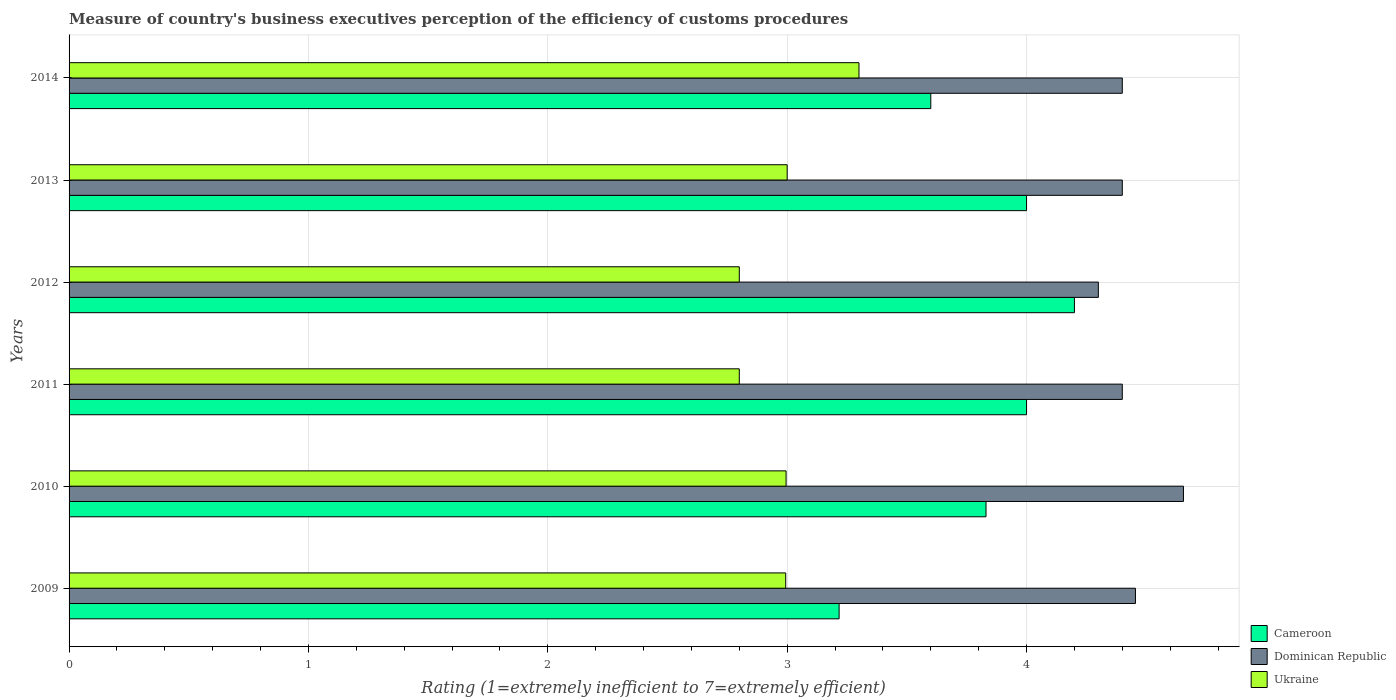How many groups of bars are there?
Give a very brief answer. 6. Are the number of bars per tick equal to the number of legend labels?
Give a very brief answer. Yes. Are the number of bars on each tick of the Y-axis equal?
Provide a succinct answer. Yes. How many bars are there on the 1st tick from the top?
Ensure brevity in your answer.  3. In how many cases, is the number of bars for a given year not equal to the number of legend labels?
Your response must be concise. 0. In which year was the rating of the efficiency of customs procedure in Dominican Republic maximum?
Keep it short and to the point. 2010. In which year was the rating of the efficiency of customs procedure in Dominican Republic minimum?
Offer a very short reply. 2012. What is the total rating of the efficiency of customs procedure in Ukraine in the graph?
Offer a terse response. 17.89. What is the difference between the rating of the efficiency of customs procedure in Ukraine in 2010 and that in 2013?
Your response must be concise. -0. What is the difference between the rating of the efficiency of customs procedure in Cameroon in 2009 and the rating of the efficiency of customs procedure in Dominican Republic in 2013?
Offer a very short reply. -1.18. What is the average rating of the efficiency of customs procedure in Dominican Republic per year?
Make the answer very short. 4.44. In the year 2014, what is the difference between the rating of the efficiency of customs procedure in Ukraine and rating of the efficiency of customs procedure in Dominican Republic?
Provide a succinct answer. -1.1. In how many years, is the rating of the efficiency of customs procedure in Cameroon greater than 2.8 ?
Your response must be concise. 6. What is the ratio of the rating of the efficiency of customs procedure in Cameroon in 2009 to that in 2010?
Offer a very short reply. 0.84. What is the difference between the highest and the second highest rating of the efficiency of customs procedure in Cameroon?
Offer a very short reply. 0.2. What is the difference between the highest and the lowest rating of the efficiency of customs procedure in Ukraine?
Make the answer very short. 0.5. Is the sum of the rating of the efficiency of customs procedure in Dominican Republic in 2010 and 2014 greater than the maximum rating of the efficiency of customs procedure in Cameroon across all years?
Provide a short and direct response. Yes. What does the 1st bar from the top in 2010 represents?
Your response must be concise. Ukraine. What does the 2nd bar from the bottom in 2009 represents?
Your answer should be very brief. Dominican Republic. Is it the case that in every year, the sum of the rating of the efficiency of customs procedure in Cameroon and rating of the efficiency of customs procedure in Ukraine is greater than the rating of the efficiency of customs procedure in Dominican Republic?
Your response must be concise. Yes. Are all the bars in the graph horizontal?
Make the answer very short. Yes. What is the difference between two consecutive major ticks on the X-axis?
Provide a short and direct response. 1. How many legend labels are there?
Your answer should be very brief. 3. What is the title of the graph?
Your response must be concise. Measure of country's business executives perception of the efficiency of customs procedures. What is the label or title of the X-axis?
Your response must be concise. Rating (1=extremely inefficient to 7=extremely efficient). What is the label or title of the Y-axis?
Offer a terse response. Years. What is the Rating (1=extremely inefficient to 7=extremely efficient) in Cameroon in 2009?
Keep it short and to the point. 3.22. What is the Rating (1=extremely inefficient to 7=extremely efficient) in Dominican Republic in 2009?
Offer a terse response. 4.46. What is the Rating (1=extremely inefficient to 7=extremely efficient) in Ukraine in 2009?
Offer a very short reply. 2.99. What is the Rating (1=extremely inefficient to 7=extremely efficient) of Cameroon in 2010?
Make the answer very short. 3.83. What is the Rating (1=extremely inefficient to 7=extremely efficient) of Dominican Republic in 2010?
Your response must be concise. 4.66. What is the Rating (1=extremely inefficient to 7=extremely efficient) in Ukraine in 2010?
Your answer should be compact. 3. What is the Rating (1=extremely inefficient to 7=extremely efficient) of Dominican Republic in 2011?
Your answer should be very brief. 4.4. What is the Rating (1=extremely inefficient to 7=extremely efficient) in Cameroon in 2012?
Give a very brief answer. 4.2. What is the Rating (1=extremely inefficient to 7=extremely efficient) in Dominican Republic in 2012?
Provide a succinct answer. 4.3. What is the Rating (1=extremely inefficient to 7=extremely efficient) in Ukraine in 2012?
Make the answer very short. 2.8. What is the Rating (1=extremely inefficient to 7=extremely efficient) of Cameroon in 2013?
Your answer should be very brief. 4. What is the Rating (1=extremely inefficient to 7=extremely efficient) of Dominican Republic in 2013?
Give a very brief answer. 4.4. What is the Rating (1=extremely inefficient to 7=extremely efficient) of Ukraine in 2013?
Provide a succinct answer. 3. What is the Rating (1=extremely inefficient to 7=extremely efficient) of Cameroon in 2014?
Make the answer very short. 3.6. What is the Rating (1=extremely inefficient to 7=extremely efficient) in Dominican Republic in 2014?
Your answer should be very brief. 4.4. Across all years, what is the maximum Rating (1=extremely inefficient to 7=extremely efficient) in Dominican Republic?
Offer a terse response. 4.66. Across all years, what is the maximum Rating (1=extremely inefficient to 7=extremely efficient) of Ukraine?
Your response must be concise. 3.3. Across all years, what is the minimum Rating (1=extremely inefficient to 7=extremely efficient) of Cameroon?
Offer a terse response. 3.22. Across all years, what is the minimum Rating (1=extremely inefficient to 7=extremely efficient) in Dominican Republic?
Give a very brief answer. 4.3. What is the total Rating (1=extremely inefficient to 7=extremely efficient) in Cameroon in the graph?
Make the answer very short. 22.85. What is the total Rating (1=extremely inefficient to 7=extremely efficient) in Dominican Republic in the graph?
Your answer should be compact. 26.61. What is the total Rating (1=extremely inefficient to 7=extremely efficient) of Ukraine in the graph?
Your answer should be compact. 17.89. What is the difference between the Rating (1=extremely inefficient to 7=extremely efficient) of Cameroon in 2009 and that in 2010?
Make the answer very short. -0.61. What is the difference between the Rating (1=extremely inefficient to 7=extremely efficient) of Dominican Republic in 2009 and that in 2010?
Offer a very short reply. -0.2. What is the difference between the Rating (1=extremely inefficient to 7=extremely efficient) in Ukraine in 2009 and that in 2010?
Offer a very short reply. -0. What is the difference between the Rating (1=extremely inefficient to 7=extremely efficient) of Cameroon in 2009 and that in 2011?
Make the answer very short. -0.78. What is the difference between the Rating (1=extremely inefficient to 7=extremely efficient) of Dominican Republic in 2009 and that in 2011?
Provide a succinct answer. 0.06. What is the difference between the Rating (1=extremely inefficient to 7=extremely efficient) of Ukraine in 2009 and that in 2011?
Your response must be concise. 0.19. What is the difference between the Rating (1=extremely inefficient to 7=extremely efficient) of Cameroon in 2009 and that in 2012?
Offer a terse response. -0.98. What is the difference between the Rating (1=extremely inefficient to 7=extremely efficient) of Dominican Republic in 2009 and that in 2012?
Ensure brevity in your answer.  0.15. What is the difference between the Rating (1=extremely inefficient to 7=extremely efficient) of Ukraine in 2009 and that in 2012?
Your answer should be compact. 0.19. What is the difference between the Rating (1=extremely inefficient to 7=extremely efficient) in Cameroon in 2009 and that in 2013?
Your answer should be compact. -0.78. What is the difference between the Rating (1=extremely inefficient to 7=extremely efficient) of Dominican Republic in 2009 and that in 2013?
Offer a very short reply. 0.06. What is the difference between the Rating (1=extremely inefficient to 7=extremely efficient) in Ukraine in 2009 and that in 2013?
Ensure brevity in your answer.  -0.01. What is the difference between the Rating (1=extremely inefficient to 7=extremely efficient) in Cameroon in 2009 and that in 2014?
Keep it short and to the point. -0.38. What is the difference between the Rating (1=extremely inefficient to 7=extremely efficient) of Dominican Republic in 2009 and that in 2014?
Keep it short and to the point. 0.06. What is the difference between the Rating (1=extremely inefficient to 7=extremely efficient) of Ukraine in 2009 and that in 2014?
Your answer should be very brief. -0.31. What is the difference between the Rating (1=extremely inefficient to 7=extremely efficient) in Cameroon in 2010 and that in 2011?
Your answer should be compact. -0.17. What is the difference between the Rating (1=extremely inefficient to 7=extremely efficient) of Dominican Republic in 2010 and that in 2011?
Offer a terse response. 0.26. What is the difference between the Rating (1=extremely inefficient to 7=extremely efficient) of Ukraine in 2010 and that in 2011?
Offer a terse response. 0.2. What is the difference between the Rating (1=extremely inefficient to 7=extremely efficient) of Cameroon in 2010 and that in 2012?
Your answer should be compact. -0.37. What is the difference between the Rating (1=extremely inefficient to 7=extremely efficient) of Dominican Republic in 2010 and that in 2012?
Provide a succinct answer. 0.36. What is the difference between the Rating (1=extremely inefficient to 7=extremely efficient) in Ukraine in 2010 and that in 2012?
Give a very brief answer. 0.2. What is the difference between the Rating (1=extremely inefficient to 7=extremely efficient) of Cameroon in 2010 and that in 2013?
Keep it short and to the point. -0.17. What is the difference between the Rating (1=extremely inefficient to 7=extremely efficient) in Dominican Republic in 2010 and that in 2013?
Your answer should be compact. 0.26. What is the difference between the Rating (1=extremely inefficient to 7=extremely efficient) in Ukraine in 2010 and that in 2013?
Provide a succinct answer. -0. What is the difference between the Rating (1=extremely inefficient to 7=extremely efficient) of Cameroon in 2010 and that in 2014?
Your answer should be compact. 0.23. What is the difference between the Rating (1=extremely inefficient to 7=extremely efficient) in Dominican Republic in 2010 and that in 2014?
Your answer should be compact. 0.26. What is the difference between the Rating (1=extremely inefficient to 7=extremely efficient) in Ukraine in 2010 and that in 2014?
Provide a succinct answer. -0.3. What is the difference between the Rating (1=extremely inefficient to 7=extremely efficient) of Cameroon in 2011 and that in 2012?
Ensure brevity in your answer.  -0.2. What is the difference between the Rating (1=extremely inefficient to 7=extremely efficient) of Ukraine in 2011 and that in 2012?
Make the answer very short. 0. What is the difference between the Rating (1=extremely inefficient to 7=extremely efficient) of Cameroon in 2011 and that in 2013?
Keep it short and to the point. 0. What is the difference between the Rating (1=extremely inefficient to 7=extremely efficient) in Dominican Republic in 2011 and that in 2013?
Your answer should be very brief. 0. What is the difference between the Rating (1=extremely inefficient to 7=extremely efficient) of Ukraine in 2011 and that in 2013?
Keep it short and to the point. -0.2. What is the difference between the Rating (1=extremely inefficient to 7=extremely efficient) in Cameroon in 2012 and that in 2013?
Make the answer very short. 0.2. What is the difference between the Rating (1=extremely inefficient to 7=extremely efficient) in Cameroon in 2012 and that in 2014?
Your response must be concise. 0.6. What is the difference between the Rating (1=extremely inefficient to 7=extremely efficient) of Dominican Republic in 2012 and that in 2014?
Keep it short and to the point. -0.1. What is the difference between the Rating (1=extremely inefficient to 7=extremely efficient) of Cameroon in 2013 and that in 2014?
Provide a succinct answer. 0.4. What is the difference between the Rating (1=extremely inefficient to 7=extremely efficient) of Ukraine in 2013 and that in 2014?
Your answer should be compact. -0.3. What is the difference between the Rating (1=extremely inefficient to 7=extremely efficient) in Cameroon in 2009 and the Rating (1=extremely inefficient to 7=extremely efficient) in Dominican Republic in 2010?
Offer a terse response. -1.44. What is the difference between the Rating (1=extremely inefficient to 7=extremely efficient) in Cameroon in 2009 and the Rating (1=extremely inefficient to 7=extremely efficient) in Ukraine in 2010?
Provide a succinct answer. 0.22. What is the difference between the Rating (1=extremely inefficient to 7=extremely efficient) of Dominican Republic in 2009 and the Rating (1=extremely inefficient to 7=extremely efficient) of Ukraine in 2010?
Give a very brief answer. 1.46. What is the difference between the Rating (1=extremely inefficient to 7=extremely efficient) in Cameroon in 2009 and the Rating (1=extremely inefficient to 7=extremely efficient) in Dominican Republic in 2011?
Ensure brevity in your answer.  -1.18. What is the difference between the Rating (1=extremely inefficient to 7=extremely efficient) in Cameroon in 2009 and the Rating (1=extremely inefficient to 7=extremely efficient) in Ukraine in 2011?
Provide a succinct answer. 0.42. What is the difference between the Rating (1=extremely inefficient to 7=extremely efficient) in Dominican Republic in 2009 and the Rating (1=extremely inefficient to 7=extremely efficient) in Ukraine in 2011?
Offer a very short reply. 1.66. What is the difference between the Rating (1=extremely inefficient to 7=extremely efficient) in Cameroon in 2009 and the Rating (1=extremely inefficient to 7=extremely efficient) in Dominican Republic in 2012?
Provide a short and direct response. -1.08. What is the difference between the Rating (1=extremely inefficient to 7=extremely efficient) of Cameroon in 2009 and the Rating (1=extremely inefficient to 7=extremely efficient) of Ukraine in 2012?
Your answer should be very brief. 0.42. What is the difference between the Rating (1=extremely inefficient to 7=extremely efficient) in Dominican Republic in 2009 and the Rating (1=extremely inefficient to 7=extremely efficient) in Ukraine in 2012?
Your answer should be very brief. 1.66. What is the difference between the Rating (1=extremely inefficient to 7=extremely efficient) in Cameroon in 2009 and the Rating (1=extremely inefficient to 7=extremely efficient) in Dominican Republic in 2013?
Ensure brevity in your answer.  -1.18. What is the difference between the Rating (1=extremely inefficient to 7=extremely efficient) in Cameroon in 2009 and the Rating (1=extremely inefficient to 7=extremely efficient) in Ukraine in 2013?
Give a very brief answer. 0.22. What is the difference between the Rating (1=extremely inefficient to 7=extremely efficient) of Dominican Republic in 2009 and the Rating (1=extremely inefficient to 7=extremely efficient) of Ukraine in 2013?
Your response must be concise. 1.46. What is the difference between the Rating (1=extremely inefficient to 7=extremely efficient) of Cameroon in 2009 and the Rating (1=extremely inefficient to 7=extremely efficient) of Dominican Republic in 2014?
Give a very brief answer. -1.18. What is the difference between the Rating (1=extremely inefficient to 7=extremely efficient) in Cameroon in 2009 and the Rating (1=extremely inefficient to 7=extremely efficient) in Ukraine in 2014?
Offer a terse response. -0.08. What is the difference between the Rating (1=extremely inefficient to 7=extremely efficient) in Dominican Republic in 2009 and the Rating (1=extremely inefficient to 7=extremely efficient) in Ukraine in 2014?
Offer a very short reply. 1.16. What is the difference between the Rating (1=extremely inefficient to 7=extremely efficient) of Cameroon in 2010 and the Rating (1=extremely inefficient to 7=extremely efficient) of Dominican Republic in 2011?
Make the answer very short. -0.57. What is the difference between the Rating (1=extremely inefficient to 7=extremely efficient) of Cameroon in 2010 and the Rating (1=extremely inefficient to 7=extremely efficient) of Ukraine in 2011?
Your answer should be compact. 1.03. What is the difference between the Rating (1=extremely inefficient to 7=extremely efficient) in Dominican Republic in 2010 and the Rating (1=extremely inefficient to 7=extremely efficient) in Ukraine in 2011?
Your answer should be very brief. 1.86. What is the difference between the Rating (1=extremely inefficient to 7=extremely efficient) of Cameroon in 2010 and the Rating (1=extremely inefficient to 7=extremely efficient) of Dominican Republic in 2012?
Provide a short and direct response. -0.47. What is the difference between the Rating (1=extremely inefficient to 7=extremely efficient) in Cameroon in 2010 and the Rating (1=extremely inefficient to 7=extremely efficient) in Ukraine in 2012?
Give a very brief answer. 1.03. What is the difference between the Rating (1=extremely inefficient to 7=extremely efficient) in Dominican Republic in 2010 and the Rating (1=extremely inefficient to 7=extremely efficient) in Ukraine in 2012?
Provide a short and direct response. 1.86. What is the difference between the Rating (1=extremely inefficient to 7=extremely efficient) of Cameroon in 2010 and the Rating (1=extremely inefficient to 7=extremely efficient) of Dominican Republic in 2013?
Keep it short and to the point. -0.57. What is the difference between the Rating (1=extremely inefficient to 7=extremely efficient) of Cameroon in 2010 and the Rating (1=extremely inefficient to 7=extremely efficient) of Ukraine in 2013?
Offer a terse response. 0.83. What is the difference between the Rating (1=extremely inefficient to 7=extremely efficient) of Dominican Republic in 2010 and the Rating (1=extremely inefficient to 7=extremely efficient) of Ukraine in 2013?
Provide a succinct answer. 1.66. What is the difference between the Rating (1=extremely inefficient to 7=extremely efficient) in Cameroon in 2010 and the Rating (1=extremely inefficient to 7=extremely efficient) in Dominican Republic in 2014?
Your answer should be very brief. -0.57. What is the difference between the Rating (1=extremely inefficient to 7=extremely efficient) in Cameroon in 2010 and the Rating (1=extremely inefficient to 7=extremely efficient) in Ukraine in 2014?
Ensure brevity in your answer.  0.53. What is the difference between the Rating (1=extremely inefficient to 7=extremely efficient) of Dominican Republic in 2010 and the Rating (1=extremely inefficient to 7=extremely efficient) of Ukraine in 2014?
Keep it short and to the point. 1.36. What is the difference between the Rating (1=extremely inefficient to 7=extremely efficient) in Cameroon in 2011 and the Rating (1=extremely inefficient to 7=extremely efficient) in Ukraine in 2012?
Keep it short and to the point. 1.2. What is the difference between the Rating (1=extremely inefficient to 7=extremely efficient) of Dominican Republic in 2011 and the Rating (1=extremely inefficient to 7=extremely efficient) of Ukraine in 2012?
Keep it short and to the point. 1.6. What is the difference between the Rating (1=extremely inefficient to 7=extremely efficient) in Dominican Republic in 2011 and the Rating (1=extremely inefficient to 7=extremely efficient) in Ukraine in 2013?
Provide a short and direct response. 1.4. What is the difference between the Rating (1=extremely inefficient to 7=extremely efficient) of Cameroon in 2011 and the Rating (1=extremely inefficient to 7=extremely efficient) of Dominican Republic in 2014?
Provide a succinct answer. -0.4. What is the difference between the Rating (1=extremely inefficient to 7=extremely efficient) of Dominican Republic in 2012 and the Rating (1=extremely inefficient to 7=extremely efficient) of Ukraine in 2013?
Offer a terse response. 1.3. What is the difference between the Rating (1=extremely inefficient to 7=extremely efficient) of Cameroon in 2012 and the Rating (1=extremely inefficient to 7=extremely efficient) of Dominican Republic in 2014?
Your answer should be compact. -0.2. What is the difference between the Rating (1=extremely inefficient to 7=extremely efficient) in Cameroon in 2012 and the Rating (1=extremely inefficient to 7=extremely efficient) in Ukraine in 2014?
Provide a short and direct response. 0.9. What is the difference between the Rating (1=extremely inefficient to 7=extremely efficient) in Cameroon in 2013 and the Rating (1=extremely inefficient to 7=extremely efficient) in Dominican Republic in 2014?
Your response must be concise. -0.4. What is the difference between the Rating (1=extremely inefficient to 7=extremely efficient) in Cameroon in 2013 and the Rating (1=extremely inefficient to 7=extremely efficient) in Ukraine in 2014?
Your answer should be compact. 0.7. What is the difference between the Rating (1=extremely inefficient to 7=extremely efficient) of Dominican Republic in 2013 and the Rating (1=extremely inefficient to 7=extremely efficient) of Ukraine in 2014?
Your answer should be compact. 1.1. What is the average Rating (1=extremely inefficient to 7=extremely efficient) in Cameroon per year?
Keep it short and to the point. 3.81. What is the average Rating (1=extremely inefficient to 7=extremely efficient) in Dominican Republic per year?
Keep it short and to the point. 4.44. What is the average Rating (1=extremely inefficient to 7=extremely efficient) of Ukraine per year?
Offer a terse response. 2.98. In the year 2009, what is the difference between the Rating (1=extremely inefficient to 7=extremely efficient) in Cameroon and Rating (1=extremely inefficient to 7=extremely efficient) in Dominican Republic?
Keep it short and to the point. -1.24. In the year 2009, what is the difference between the Rating (1=extremely inefficient to 7=extremely efficient) in Cameroon and Rating (1=extremely inefficient to 7=extremely efficient) in Ukraine?
Your answer should be compact. 0.22. In the year 2009, what is the difference between the Rating (1=extremely inefficient to 7=extremely efficient) of Dominican Republic and Rating (1=extremely inefficient to 7=extremely efficient) of Ukraine?
Your response must be concise. 1.46. In the year 2010, what is the difference between the Rating (1=extremely inefficient to 7=extremely efficient) of Cameroon and Rating (1=extremely inefficient to 7=extremely efficient) of Dominican Republic?
Provide a succinct answer. -0.82. In the year 2010, what is the difference between the Rating (1=extremely inefficient to 7=extremely efficient) in Cameroon and Rating (1=extremely inefficient to 7=extremely efficient) in Ukraine?
Ensure brevity in your answer.  0.84. In the year 2010, what is the difference between the Rating (1=extremely inefficient to 7=extremely efficient) in Dominican Republic and Rating (1=extremely inefficient to 7=extremely efficient) in Ukraine?
Your answer should be compact. 1.66. In the year 2011, what is the difference between the Rating (1=extremely inefficient to 7=extremely efficient) of Dominican Republic and Rating (1=extremely inefficient to 7=extremely efficient) of Ukraine?
Provide a succinct answer. 1.6. In the year 2012, what is the difference between the Rating (1=extremely inefficient to 7=extremely efficient) in Cameroon and Rating (1=extremely inefficient to 7=extremely efficient) in Ukraine?
Keep it short and to the point. 1.4. In the year 2013, what is the difference between the Rating (1=extremely inefficient to 7=extremely efficient) in Cameroon and Rating (1=extremely inefficient to 7=extremely efficient) in Dominican Republic?
Provide a succinct answer. -0.4. In the year 2013, what is the difference between the Rating (1=extremely inefficient to 7=extremely efficient) of Dominican Republic and Rating (1=extremely inefficient to 7=extremely efficient) of Ukraine?
Provide a short and direct response. 1.4. In the year 2014, what is the difference between the Rating (1=extremely inefficient to 7=extremely efficient) in Cameroon and Rating (1=extremely inefficient to 7=extremely efficient) in Dominican Republic?
Ensure brevity in your answer.  -0.8. In the year 2014, what is the difference between the Rating (1=extremely inefficient to 7=extremely efficient) of Dominican Republic and Rating (1=extremely inefficient to 7=extremely efficient) of Ukraine?
Provide a short and direct response. 1.1. What is the ratio of the Rating (1=extremely inefficient to 7=extremely efficient) in Cameroon in 2009 to that in 2010?
Give a very brief answer. 0.84. What is the ratio of the Rating (1=extremely inefficient to 7=extremely efficient) in Dominican Republic in 2009 to that in 2010?
Keep it short and to the point. 0.96. What is the ratio of the Rating (1=extremely inefficient to 7=extremely efficient) in Ukraine in 2009 to that in 2010?
Make the answer very short. 1. What is the ratio of the Rating (1=extremely inefficient to 7=extremely efficient) of Cameroon in 2009 to that in 2011?
Your answer should be compact. 0.8. What is the ratio of the Rating (1=extremely inefficient to 7=extremely efficient) of Dominican Republic in 2009 to that in 2011?
Give a very brief answer. 1.01. What is the ratio of the Rating (1=extremely inefficient to 7=extremely efficient) in Ukraine in 2009 to that in 2011?
Provide a succinct answer. 1.07. What is the ratio of the Rating (1=extremely inefficient to 7=extremely efficient) of Cameroon in 2009 to that in 2012?
Keep it short and to the point. 0.77. What is the ratio of the Rating (1=extremely inefficient to 7=extremely efficient) of Dominican Republic in 2009 to that in 2012?
Your response must be concise. 1.04. What is the ratio of the Rating (1=extremely inefficient to 7=extremely efficient) of Ukraine in 2009 to that in 2012?
Your answer should be compact. 1.07. What is the ratio of the Rating (1=extremely inefficient to 7=extremely efficient) in Cameroon in 2009 to that in 2013?
Keep it short and to the point. 0.8. What is the ratio of the Rating (1=extremely inefficient to 7=extremely efficient) in Dominican Republic in 2009 to that in 2013?
Your answer should be very brief. 1.01. What is the ratio of the Rating (1=extremely inefficient to 7=extremely efficient) in Cameroon in 2009 to that in 2014?
Your response must be concise. 0.89. What is the ratio of the Rating (1=extremely inefficient to 7=extremely efficient) in Dominican Republic in 2009 to that in 2014?
Your answer should be very brief. 1.01. What is the ratio of the Rating (1=extremely inefficient to 7=extremely efficient) of Ukraine in 2009 to that in 2014?
Give a very brief answer. 0.91. What is the ratio of the Rating (1=extremely inefficient to 7=extremely efficient) in Cameroon in 2010 to that in 2011?
Offer a terse response. 0.96. What is the ratio of the Rating (1=extremely inefficient to 7=extremely efficient) of Dominican Republic in 2010 to that in 2011?
Make the answer very short. 1.06. What is the ratio of the Rating (1=extremely inefficient to 7=extremely efficient) of Ukraine in 2010 to that in 2011?
Your answer should be very brief. 1.07. What is the ratio of the Rating (1=extremely inefficient to 7=extremely efficient) in Cameroon in 2010 to that in 2012?
Ensure brevity in your answer.  0.91. What is the ratio of the Rating (1=extremely inefficient to 7=extremely efficient) in Dominican Republic in 2010 to that in 2012?
Make the answer very short. 1.08. What is the ratio of the Rating (1=extremely inefficient to 7=extremely efficient) of Ukraine in 2010 to that in 2012?
Make the answer very short. 1.07. What is the ratio of the Rating (1=extremely inefficient to 7=extremely efficient) of Cameroon in 2010 to that in 2013?
Make the answer very short. 0.96. What is the ratio of the Rating (1=extremely inefficient to 7=extremely efficient) in Dominican Republic in 2010 to that in 2013?
Your answer should be very brief. 1.06. What is the ratio of the Rating (1=extremely inefficient to 7=extremely efficient) of Cameroon in 2010 to that in 2014?
Your answer should be compact. 1.06. What is the ratio of the Rating (1=extremely inefficient to 7=extremely efficient) in Dominican Republic in 2010 to that in 2014?
Your answer should be very brief. 1.06. What is the ratio of the Rating (1=extremely inefficient to 7=extremely efficient) of Ukraine in 2010 to that in 2014?
Offer a very short reply. 0.91. What is the ratio of the Rating (1=extremely inefficient to 7=extremely efficient) of Cameroon in 2011 to that in 2012?
Your answer should be compact. 0.95. What is the ratio of the Rating (1=extremely inefficient to 7=extremely efficient) of Dominican Republic in 2011 to that in 2012?
Your response must be concise. 1.02. What is the ratio of the Rating (1=extremely inefficient to 7=extremely efficient) in Ukraine in 2011 to that in 2012?
Your response must be concise. 1. What is the ratio of the Rating (1=extremely inefficient to 7=extremely efficient) in Cameroon in 2011 to that in 2013?
Provide a succinct answer. 1. What is the ratio of the Rating (1=extremely inefficient to 7=extremely efficient) of Dominican Republic in 2011 to that in 2013?
Your answer should be compact. 1. What is the ratio of the Rating (1=extremely inefficient to 7=extremely efficient) in Ukraine in 2011 to that in 2014?
Provide a short and direct response. 0.85. What is the ratio of the Rating (1=extremely inefficient to 7=extremely efficient) in Cameroon in 2012 to that in 2013?
Offer a terse response. 1.05. What is the ratio of the Rating (1=extremely inefficient to 7=extremely efficient) of Dominican Republic in 2012 to that in 2013?
Offer a very short reply. 0.98. What is the ratio of the Rating (1=extremely inefficient to 7=extremely efficient) in Dominican Republic in 2012 to that in 2014?
Keep it short and to the point. 0.98. What is the ratio of the Rating (1=extremely inefficient to 7=extremely efficient) in Ukraine in 2012 to that in 2014?
Your response must be concise. 0.85. What is the ratio of the Rating (1=extremely inefficient to 7=extremely efficient) of Ukraine in 2013 to that in 2014?
Provide a short and direct response. 0.91. What is the difference between the highest and the second highest Rating (1=extremely inefficient to 7=extremely efficient) of Dominican Republic?
Provide a succinct answer. 0.2. What is the difference between the highest and the second highest Rating (1=extremely inefficient to 7=extremely efficient) of Ukraine?
Your response must be concise. 0.3. What is the difference between the highest and the lowest Rating (1=extremely inefficient to 7=extremely efficient) of Cameroon?
Offer a terse response. 0.98. What is the difference between the highest and the lowest Rating (1=extremely inefficient to 7=extremely efficient) of Dominican Republic?
Make the answer very short. 0.36. What is the difference between the highest and the lowest Rating (1=extremely inefficient to 7=extremely efficient) of Ukraine?
Keep it short and to the point. 0.5. 